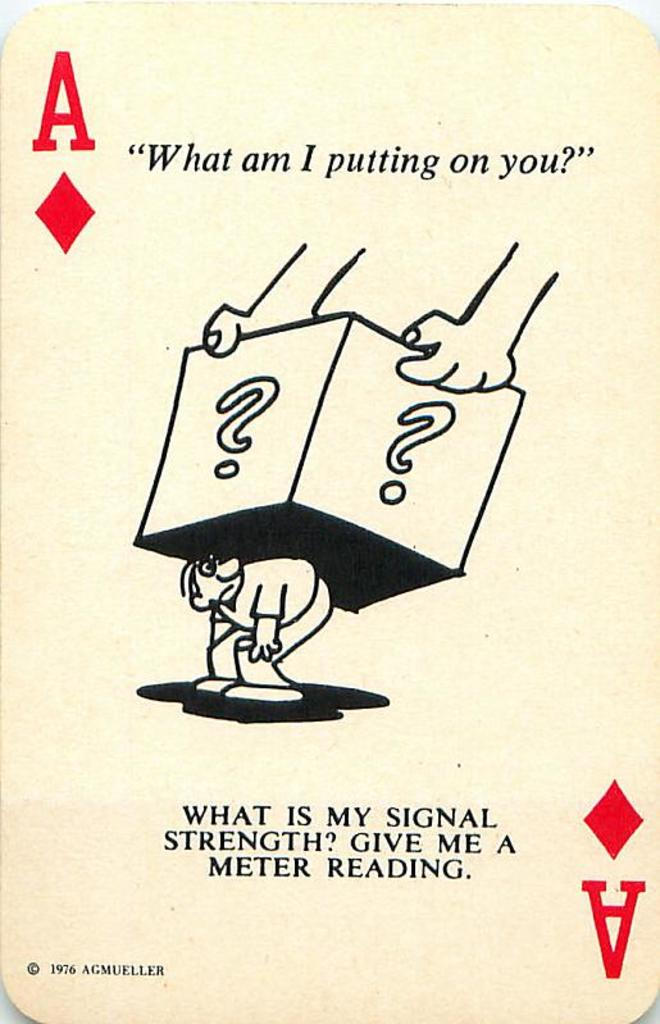How does the depiction of the cartoon character relate to the questions posed on the card? The cartoon character, shown weighed down by question-mark laden boxes, symbolizes burden or confusion, which ties directly into the questions on the card. 'What am I putting on you?' could be viewed metaphorically about the pressures or doubts one might feel, while 'What is my signal strength? Give me a meter reading.' could allude to how well one is handling these pressures or communicating under strain. The interplay between the visual and textual elements invites viewers to reflect on their personal experiences with stress and interpersonal communication. 